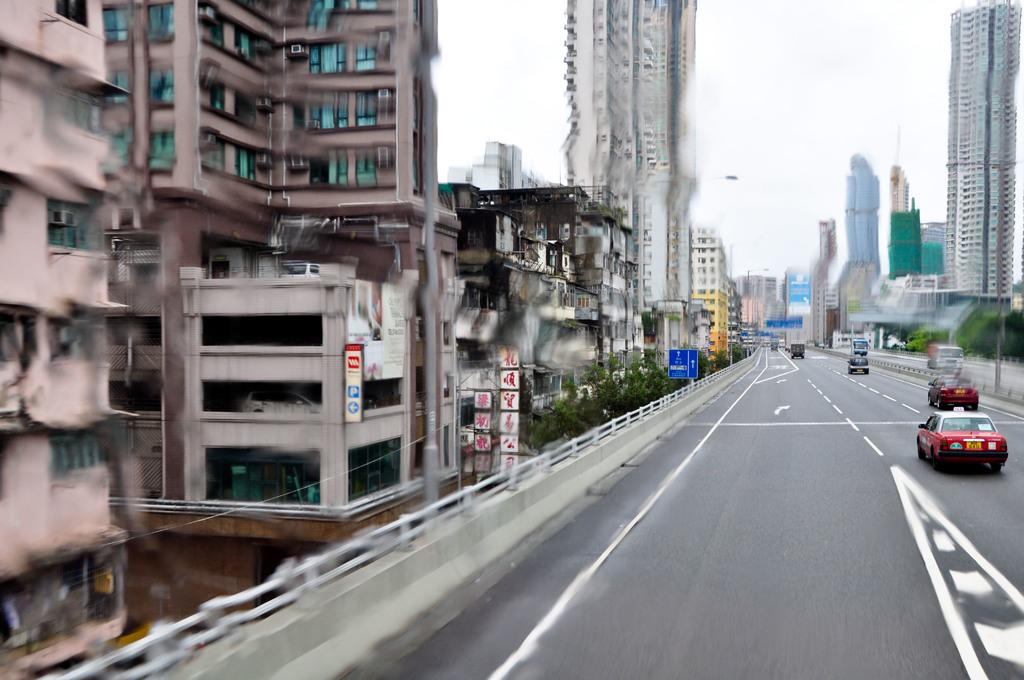What is happening on the right side of the image? There are vehicles moving on the road in the image. Can you describe the location of the vehicles in the image? The vehicles are on the right side of the image. What type of vegetation is present on either side of the image? There are trees on either side of the image. What type of structures are present on either side of the image? There are buildings on either side of the image. What is visible at the top of the image? The sky is visible at the top of the image. What type of soda is being served at the restaurant in the image? There is no restaurant or soda present in the image; it features vehicles moving on the road with trees, buildings, and the sky visible. 